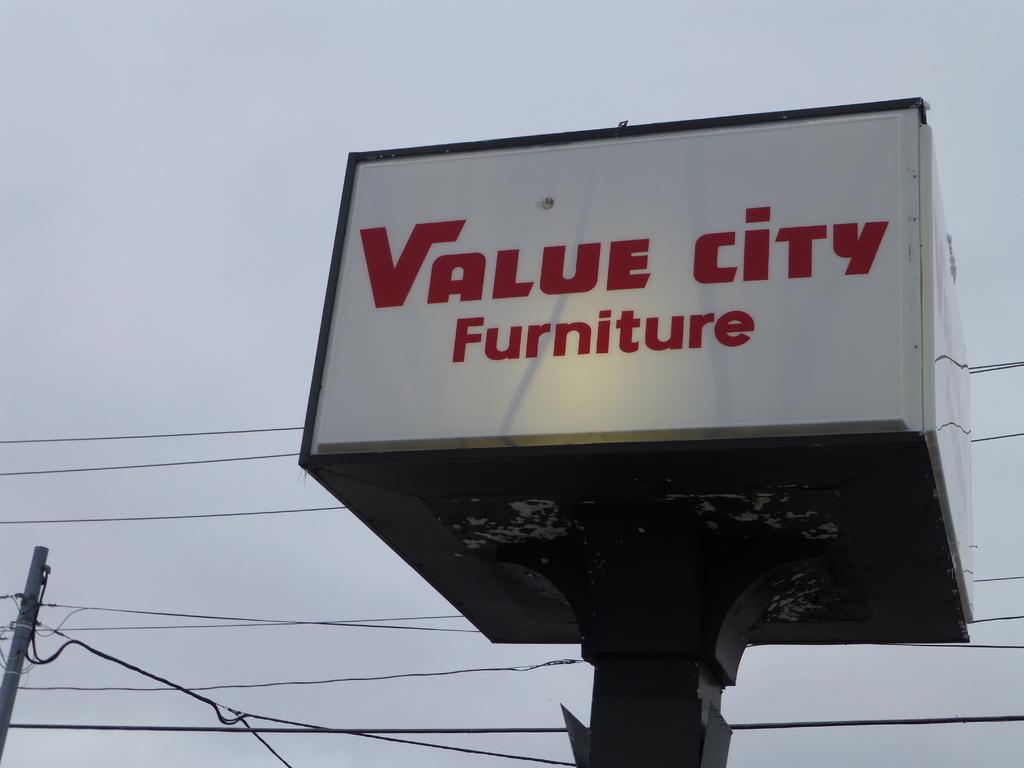What is the name of the store?
Make the answer very short. Value city furniture. What does this store sell?
Your answer should be compact. Furniture. 